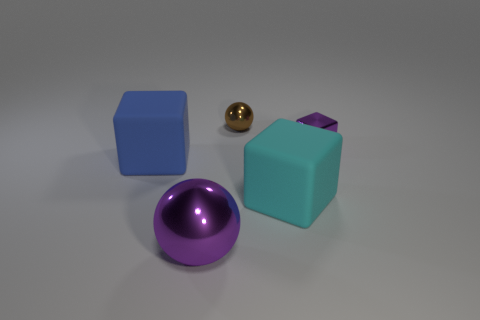What materials do the objects in the image seem to be made of? The objects in the image appear to be rendered with different types of materials. The two cubes look like they're made of a matte plastic, the sphere seems to be metallic and reflective, and the purple object has a smooth, perhaps glossy finish, potentially resembling polished stone or painted metal. 